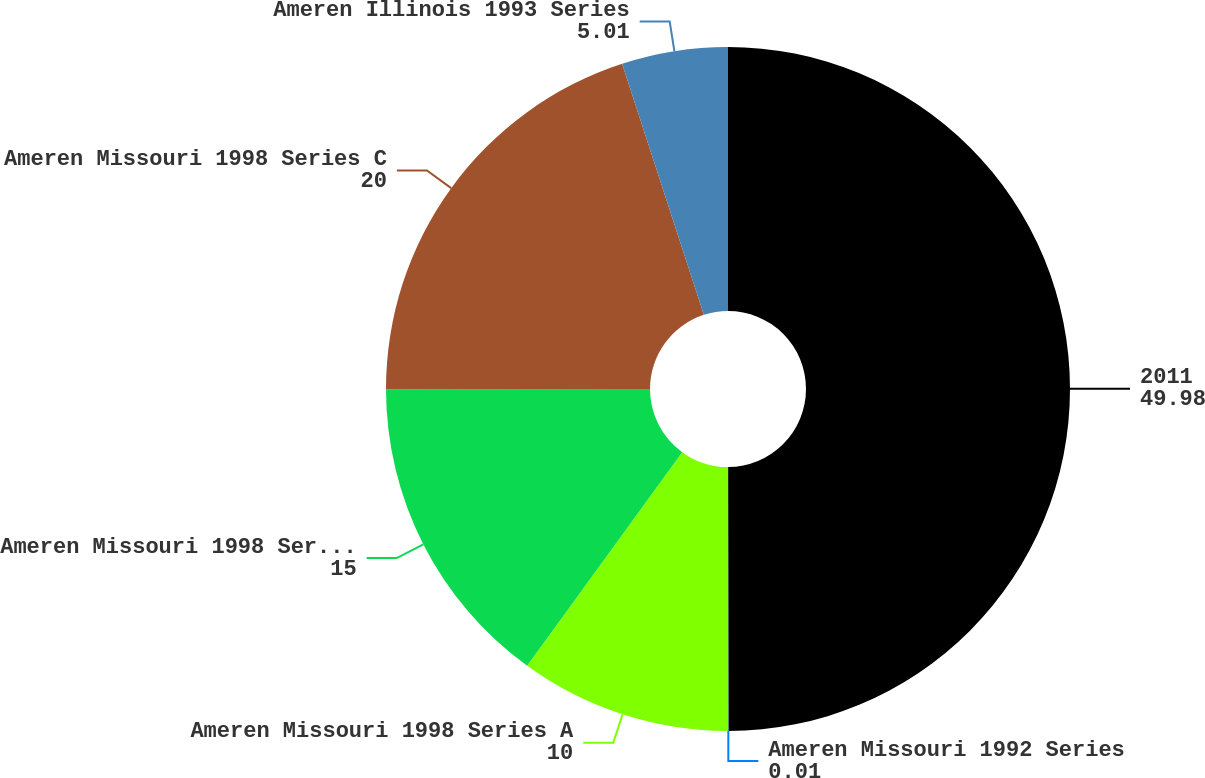Convert chart to OTSL. <chart><loc_0><loc_0><loc_500><loc_500><pie_chart><fcel>2011<fcel>Ameren Missouri 1992 Series<fcel>Ameren Missouri 1998 Series A<fcel>Ameren Missouri 1998 Series B<fcel>Ameren Missouri 1998 Series C<fcel>Ameren Illinois 1993 Series<nl><fcel>49.98%<fcel>0.01%<fcel>10.0%<fcel>15.0%<fcel>20.0%<fcel>5.01%<nl></chart> 